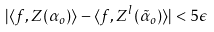<formula> <loc_0><loc_0><loc_500><loc_500>| \langle f , Z ( \alpha _ { o } ) \rangle - \langle f , Z ^ { l } ( \tilde { \alpha } _ { o } ) \rangle | < 5 \epsilon</formula> 